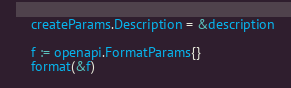<code> <loc_0><loc_0><loc_500><loc_500><_Go_>	createParams.Description = &description

	f := openapi.FormatParams{}
	format(&f)
</code> 